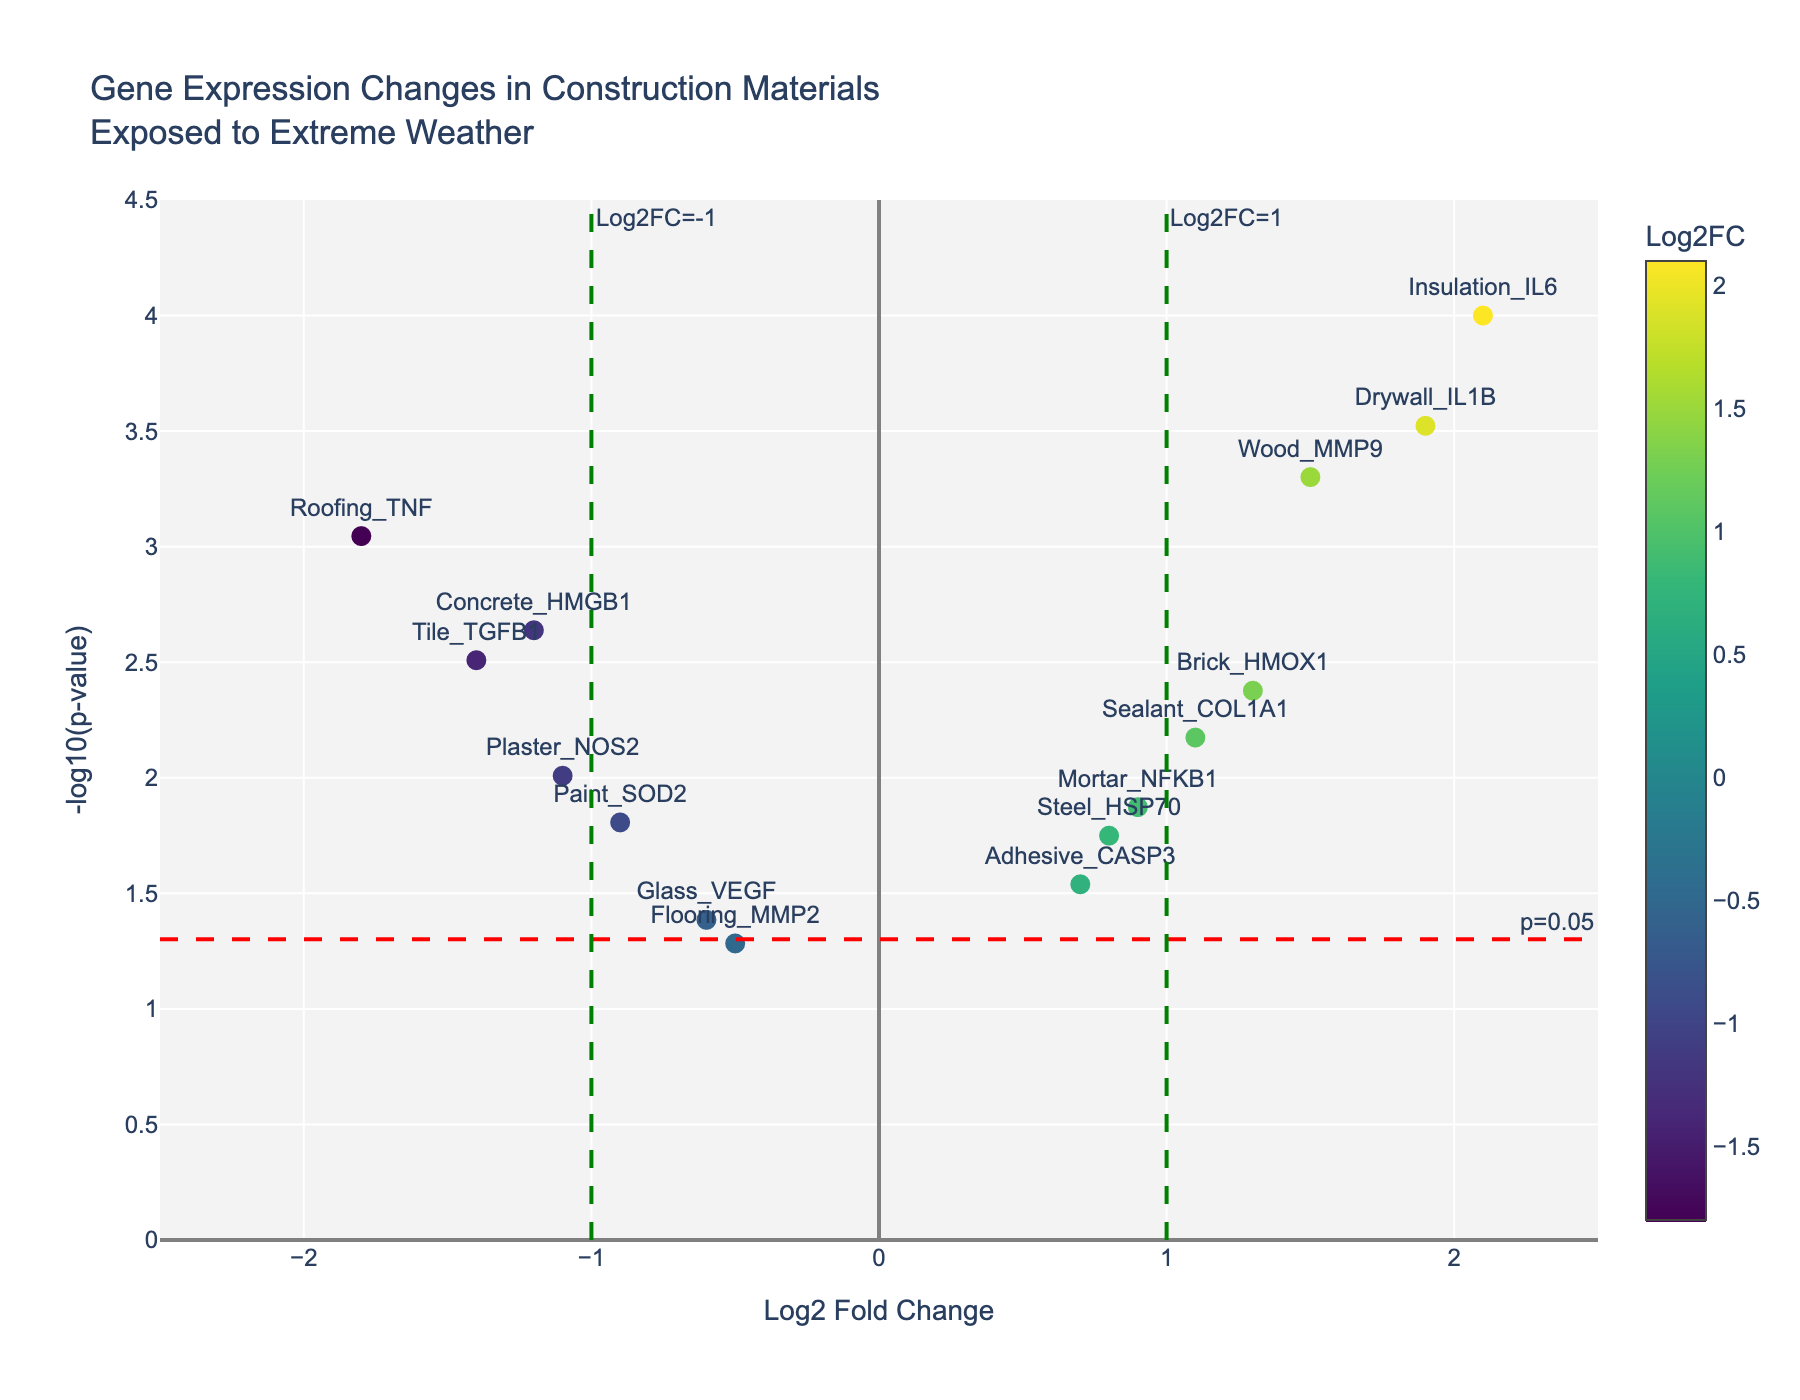what is the title of the plot? The title of the plot is displayed at the top of the figure. It reads "Gene Expression Changes in Construction Materials Exposed to Extreme Weather."
Answer: Gene Expression Changes in Construction Materials Exposed to Extreme Weather How many data points lie above the red horizontal threshold line? The horizontal threshold line represents a p-value of 0.05. To count the data points above this line, look for points with -log10(p-value) greater than approximately 1.3. There are 14 data points above this threshold.
Answer: 14 Which gene has the highest -log10(p-value)? To find the gene with the highest -log10(p-value), locate the point that is positioned highest on the y-axis. The point corresponding to Insulation_IL6 is the highest.
Answer: Insulation_IL6 What is the Log2 Fold Change value for the gene with the smallest p-value? The smallest p-value corresponds to the highest -log10(p-value). The gene with the smallest p-value is Insulation_IL6, with a Log2FC of 2.1.
Answer: 2.1 Which material has the most significant down-regulation? Down-regulation is represented by negative Log2 Fold Change values. The most significant down-regulation corresponds to the lowest value on the x-axis. Roofing_TNF has the most significant down-regulation with a Log2FC of -1.8.
Answer: Roofing_TNF How many genes have a Log2FC greater than 1? To determine this, count the number of points with Log2FC (x-axis) values greater than 1. There are 3 genes (Wood_MMP9, Insulation_IL6, and Drywall_IL1B) satisfying this condition.
Answer: 3 What is the relationship between Concrete_HMGB1 and Plaster_NOS2 in terms of Log2FC and -log10(p-value)? Concrete_HMGB1 has a Log2FC of -1.2 and -log10(p-value) of approximately 2.64. Plaster_NOS2 has a Log2FC of -1.1 and a -log10(p-value) of approximately 2.01. Hence, Concrete_HMGB1 has a slightly more negative Log2FC and a slightly higher -log10(p-value) than Plaster_NOS2.
Answer: Concrete_HMGB1 is more down-regulated and more statistically significant than Plaster_NOS2 Which material gene is closest to the Log2FC threshold of +1? Look for the point nearest the +1 threshold on the x-axis. Sealant_COL1A1 and Mortar_NFKB1 are both close, but Mortar_NFKB1 aligns more closely.
Answer: Mortar_NFKB1 How many points are within the region bounded by the vertical lines at Log2FC of -1 and +1, and above the horizontal line at -log10(p-value) of 1.3? Look for points between -1 and +1 on the x-axis and above 1.3 on the y-axis. There are 5 points fitting this description: Steel_HSP70, Glass_VEGF, Adhesive_CASP3, Paint_SOD2, and Mortar_NFKB1.
Answer: 5 